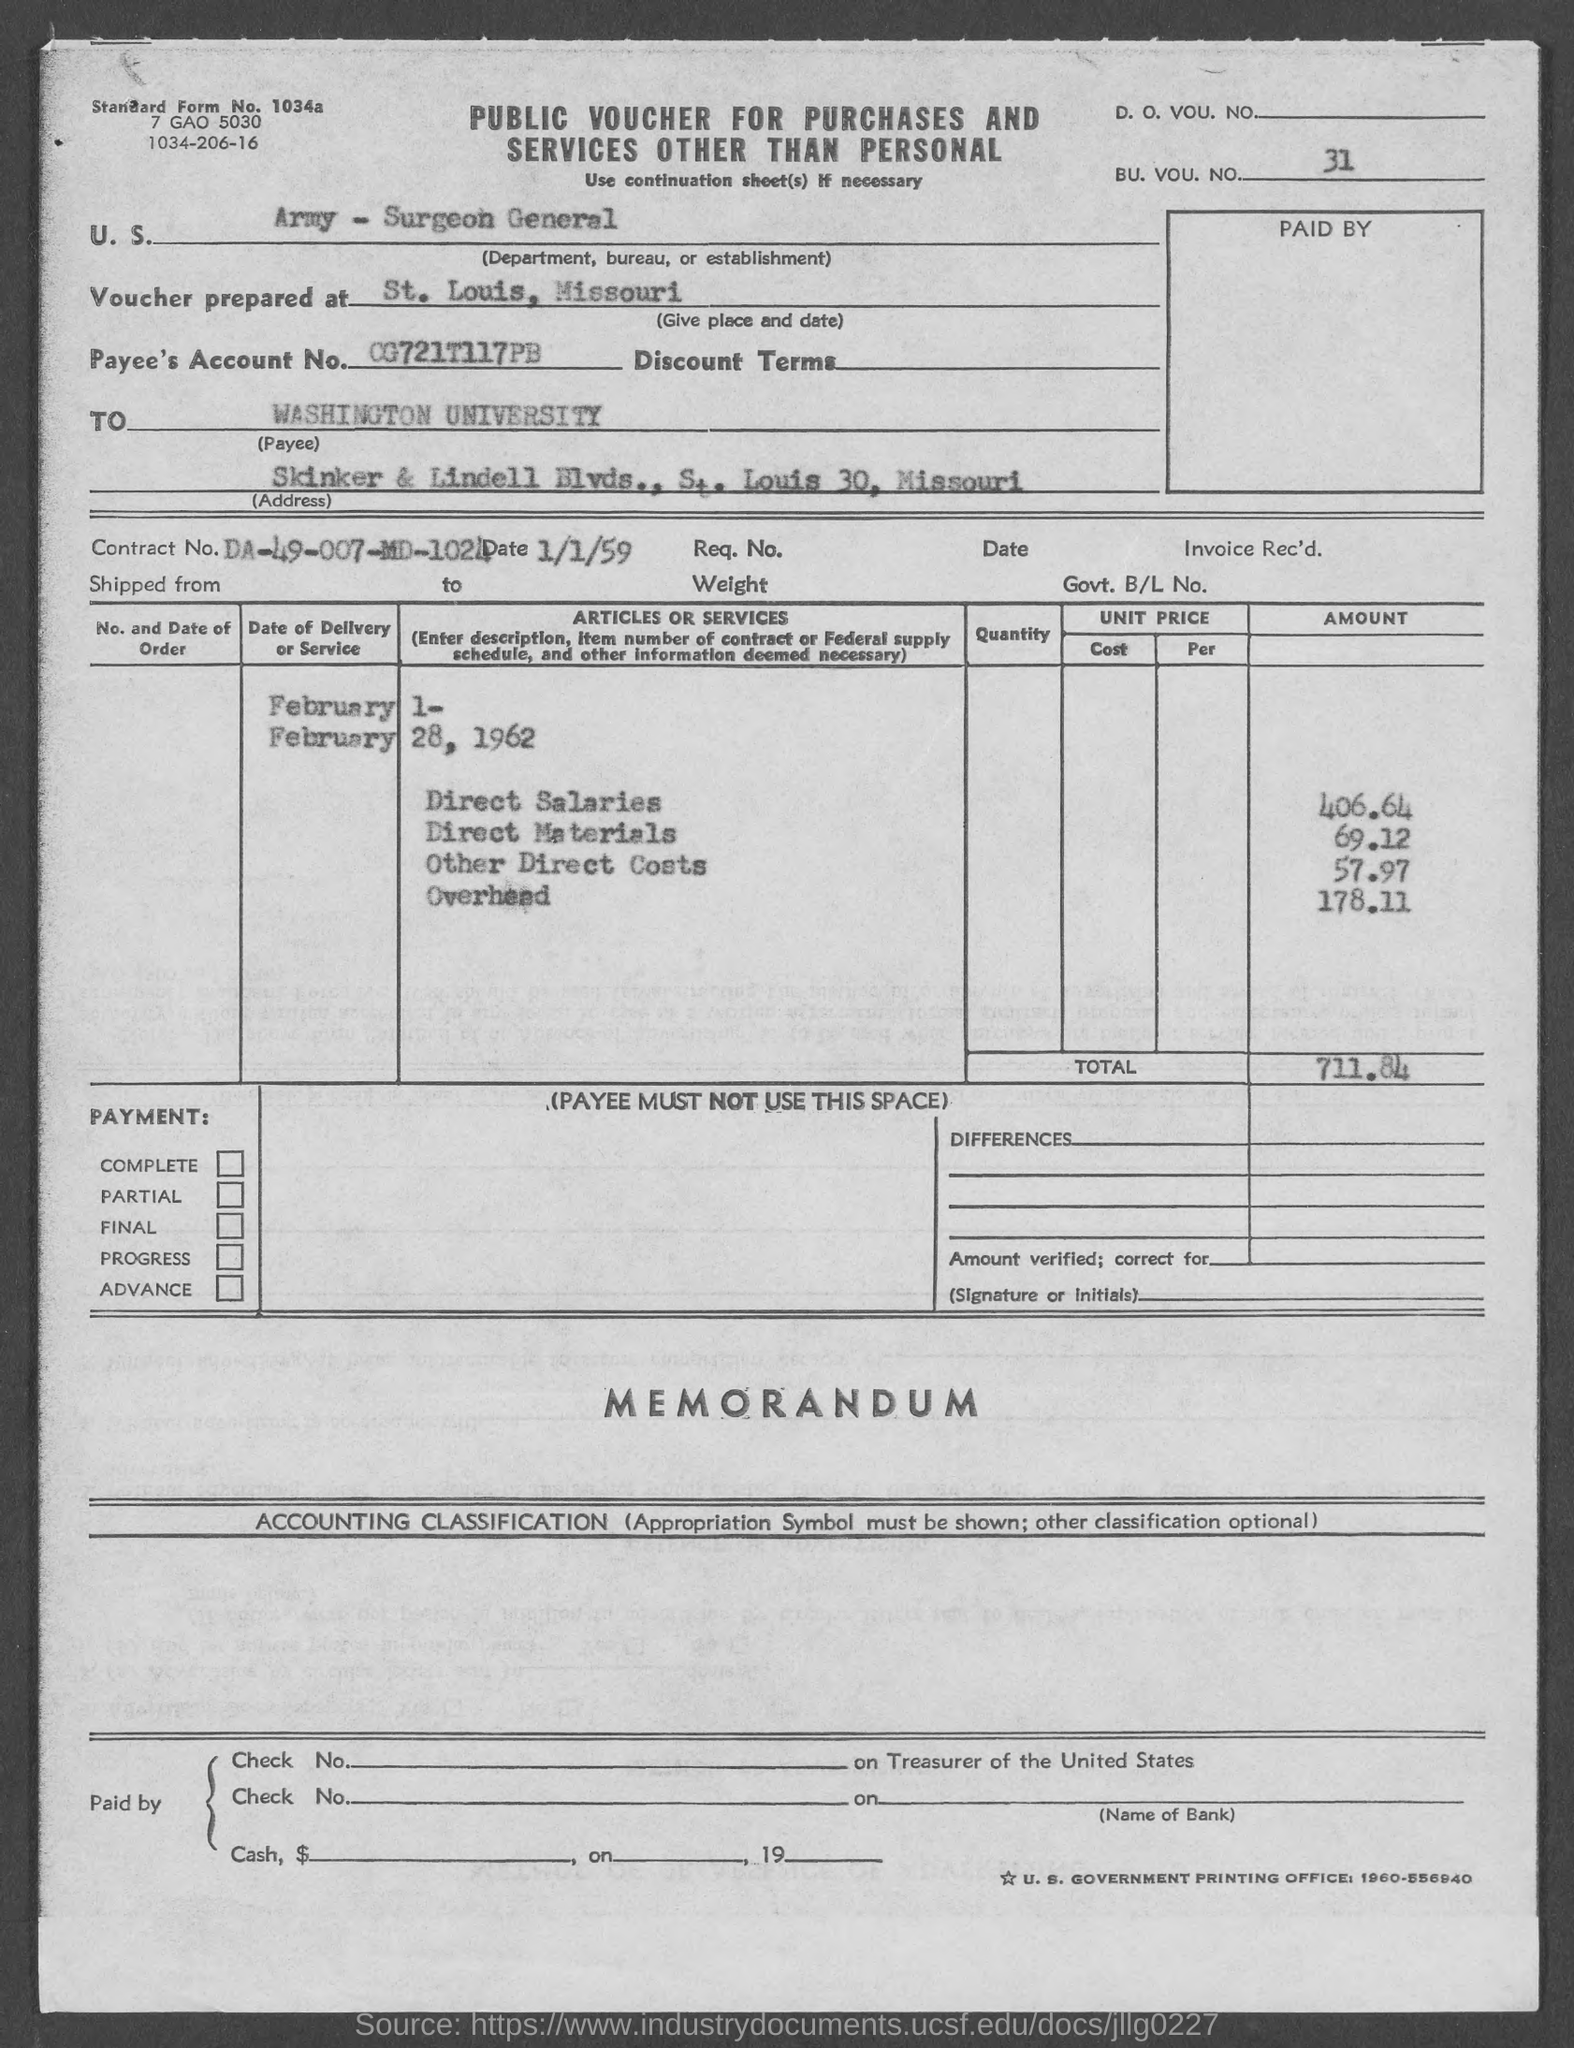In which place voucher prepared at?
Make the answer very short. St. Louis, Missouri. What is the name of the payee?
Your response must be concise. WASHINGTON UNIVERSITY. 